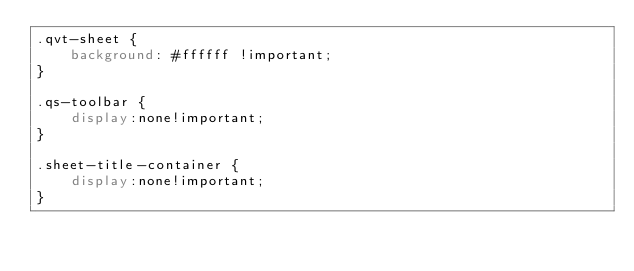Convert code to text. <code><loc_0><loc_0><loc_500><loc_500><_CSS_>.qvt-sheet {
    background: #ffffff !important;
}

.qs-toolbar {
    display:none!important;
}

.sheet-title-container {
    display:none!important;
}

</code> 